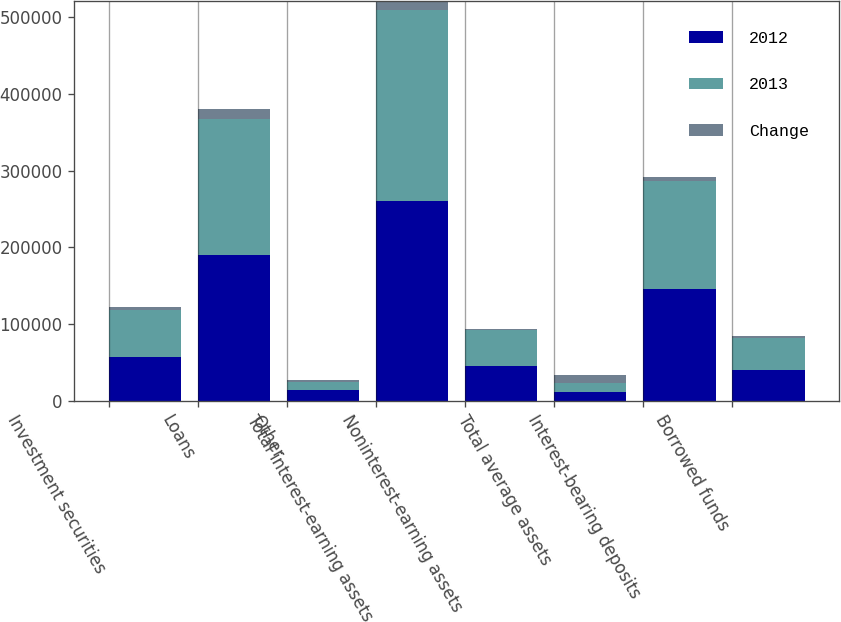Convert chart. <chart><loc_0><loc_0><loc_500><loc_500><stacked_bar_chart><ecel><fcel>Investment securities<fcel>Loans<fcel>Other<fcel>Total interest-earning assets<fcel>Noninterest-earning assets<fcel>Total average assets<fcel>Interest-bearing deposits<fcel>Borrowed funds<nl><fcel>2012<fcel>57319<fcel>189973<fcel>13353<fcel>260645<fcel>45121<fcel>11605.5<fcel>146000<fcel>40022<nl><fcel>2013<fcel>60816<fcel>176618<fcel>11120<fcel>248554<fcel>46471<fcel>11605.5<fcel>139942<fcel>41844<nl><fcel>Change<fcel>3497<fcel>13355<fcel>2233<fcel>12091<fcel>1350<fcel>10741<fcel>6058<fcel>1822<nl><fcel>nan<fcel>6<fcel>8<fcel>20<fcel>5<fcel>3<fcel>4<fcel>4<fcel>4<nl></chart> 